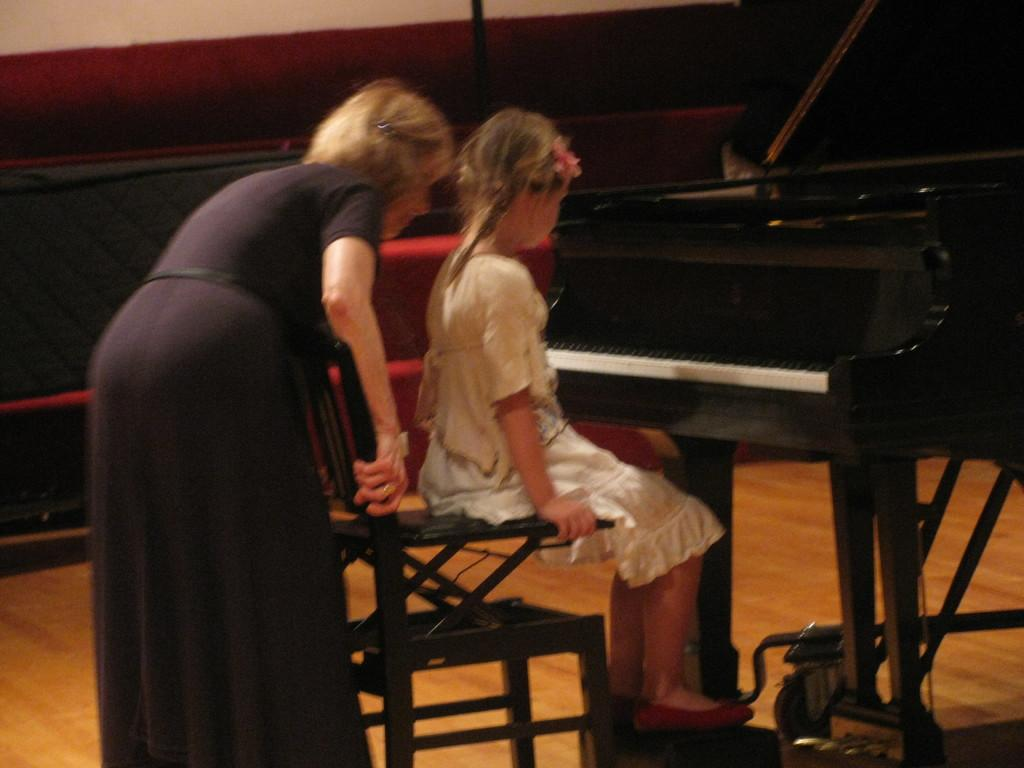How many people are in the image? There are two persons in the image. What are the positions of the two people in the image? One person is standing, and the other person is sitting. What can be seen on the right side of the image? There is a piano on the right side of the image. What type of protest is happening in the image? There is no protest present in the image; it features two people with one standing and the other sitting, along with a piano. What time is it according to the clock in the image? There is no clock present in the image. 